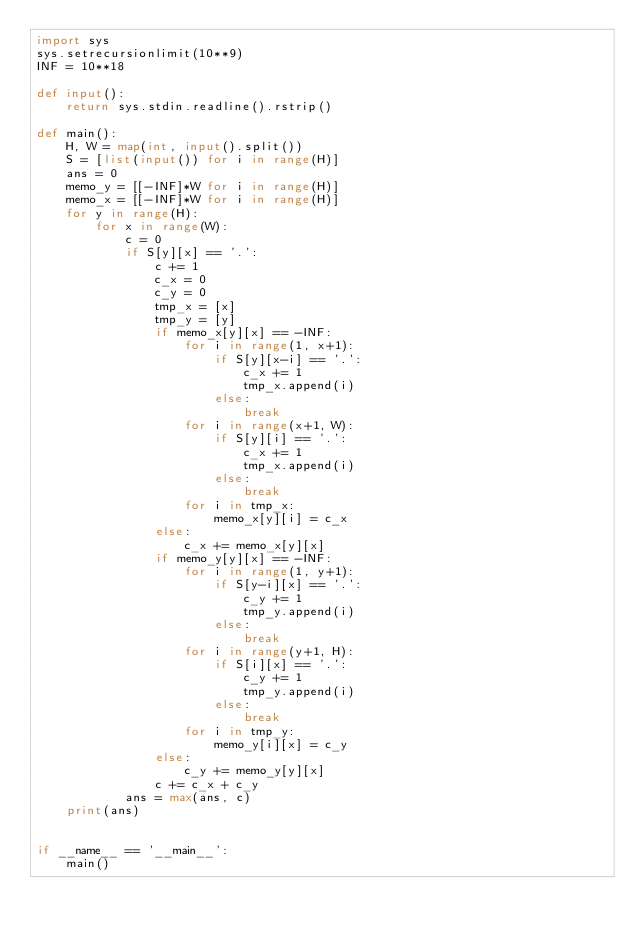<code> <loc_0><loc_0><loc_500><loc_500><_Python_>import sys
sys.setrecursionlimit(10**9)
INF = 10**18

def input():
    return sys.stdin.readline().rstrip()

def main():
    H, W = map(int, input().split())
    S = [list(input()) for i in range(H)]
    ans = 0
    memo_y = [[-INF]*W for i in range(H)]
    memo_x = [[-INF]*W for i in range(H)]
    for y in range(H):
        for x in range(W):
            c = 0
            if S[y][x] == '.':
                c += 1
                c_x = 0
                c_y = 0
                tmp_x = [x]
                tmp_y = [y]
                if memo_x[y][x] == -INF:
                    for i in range(1, x+1):
                        if S[y][x-i] == '.':
                            c_x += 1
                            tmp_x.append(i)
                        else:
                            break
                    for i in range(x+1, W):
                        if S[y][i] == '.':
                            c_x += 1
                            tmp_x.append(i)
                        else:
                            break
                    for i in tmp_x:
                        memo_x[y][i] = c_x
                else:
                    c_x += memo_x[y][x]
                if memo_y[y][x] == -INF:
                    for i in range(1, y+1):
                        if S[y-i][x] == '.':
                            c_y += 1
                            tmp_y.append(i)
                        else:
                            break
                    for i in range(y+1, H):
                        if S[i][x] == '.':
                            c_y += 1
                            tmp_y.append(i)
                        else:
                            break
                    for i in tmp_y:
                        memo_y[i][x] = c_y
                else:
                    c_y += memo_y[y][x]
                c += c_x + c_y
            ans = max(ans, c)
    print(ans)


if __name__ == '__main__':
    main()
</code> 